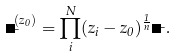<formula> <loc_0><loc_0><loc_500><loc_500>\Psi _ { \mu } ^ { ( z _ { 0 } ) } = \prod _ { i } ^ { N } ( z _ { i } - z _ { 0 } ) ^ { \frac { 1 } { n } } \Psi _ { \mu } .</formula> 